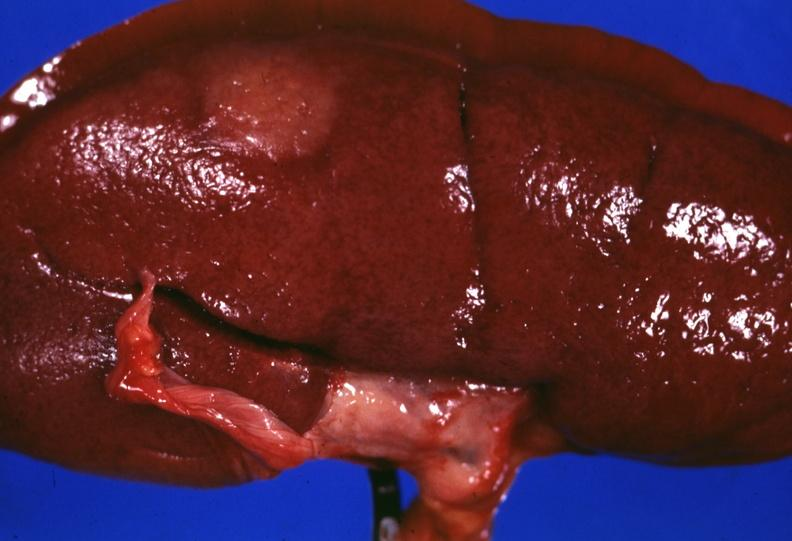what is present?
Answer the question using a single word or phrase. Kidney 